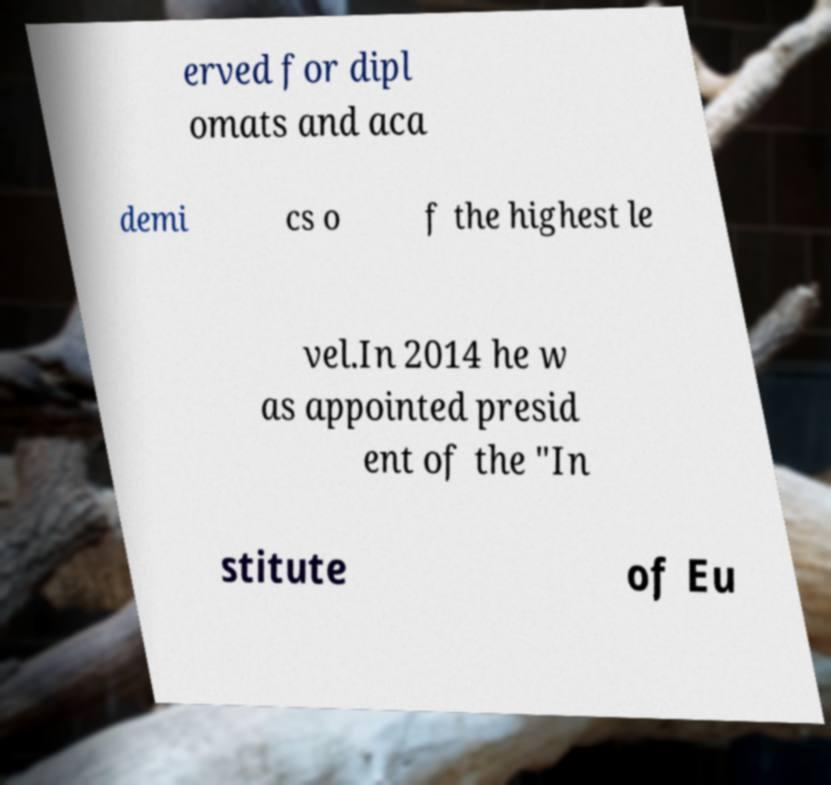What messages or text are displayed in this image? I need them in a readable, typed format. erved for dipl omats and aca demi cs o f the highest le vel.In 2014 he w as appointed presid ent of the "In stitute of Eu 